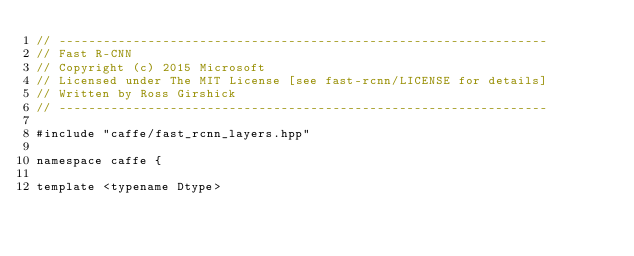<code> <loc_0><loc_0><loc_500><loc_500><_Cuda_>// ------------------------------------------------------------------
// Fast R-CNN
// Copyright (c) 2015 Microsoft
// Licensed under The MIT License [see fast-rcnn/LICENSE for details]
// Written by Ross Girshick
// ------------------------------------------------------------------

#include "caffe/fast_rcnn_layers.hpp"

namespace caffe {

template <typename Dtype></code> 